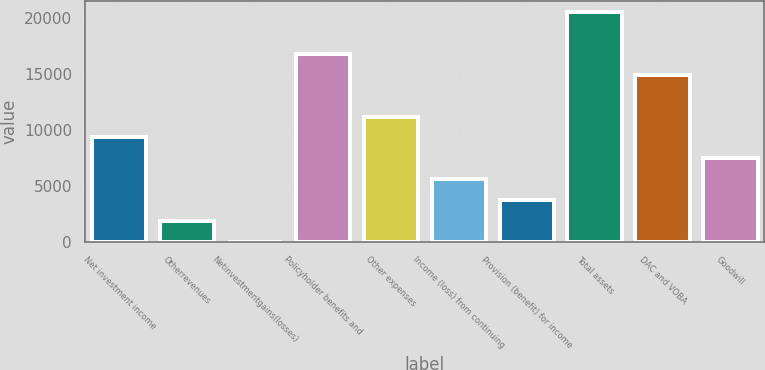Convert chart to OTSL. <chart><loc_0><loc_0><loc_500><loc_500><bar_chart><fcel>Net investment income<fcel>Otherrevenues<fcel>Netinvestmentgains(losses)<fcel>Policyholder benefits and<fcel>Other expenses<fcel>Income (loss) from continuing<fcel>Provision (benefit) for income<fcel>Total assets<fcel>DAC and VOBA<fcel>Goodwill<nl><fcel>9314.5<fcel>1866.9<fcel>5<fcel>16762.1<fcel>11176.4<fcel>5590.7<fcel>3728.8<fcel>20485.9<fcel>14900.2<fcel>7452.6<nl></chart> 